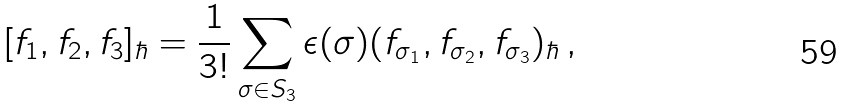<formula> <loc_0><loc_0><loc_500><loc_500>[ f _ { 1 } , f _ { 2 } , f _ { 3 } ] _ { \hbar } = \frac { 1 } { 3 ! } \sum _ { \sigma \in S _ { 3 } } \epsilon ( \sigma ) ( f _ { \sigma _ { 1 } } , f _ { \sigma _ { 2 } } , f _ { \sigma _ { 3 } } ) _ { \hbar } \, ,</formula> 